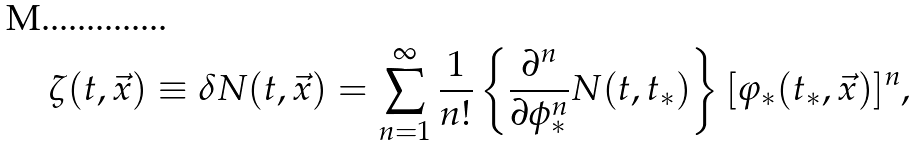<formula> <loc_0><loc_0><loc_500><loc_500>\zeta ( t , \vec { x } ) \equiv \delta N ( t , \vec { x } ) = \sum _ { n = 1 } ^ { \infty } \frac { 1 } { n ! } \left \{ \frac { \partial ^ { n } } { \partial \phi _ { \ast } ^ { n } } N ( t , t _ { \ast } ) \right \} [ \varphi _ { \ast } ( t _ { \ast } , \vec { x } ) ] ^ { n } ,</formula> 